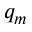Convert formula to latex. <formula><loc_0><loc_0><loc_500><loc_500>q _ { m }</formula> 